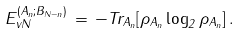Convert formula to latex. <formula><loc_0><loc_0><loc_500><loc_500>E _ { v N } ^ { ( A _ { n } ; B _ { N - n } ) } \, = \, - T r _ { A _ { n } } [ \rho _ { A _ { n } } \log _ { 2 } \rho _ { A _ { n } } ] \, .</formula> 